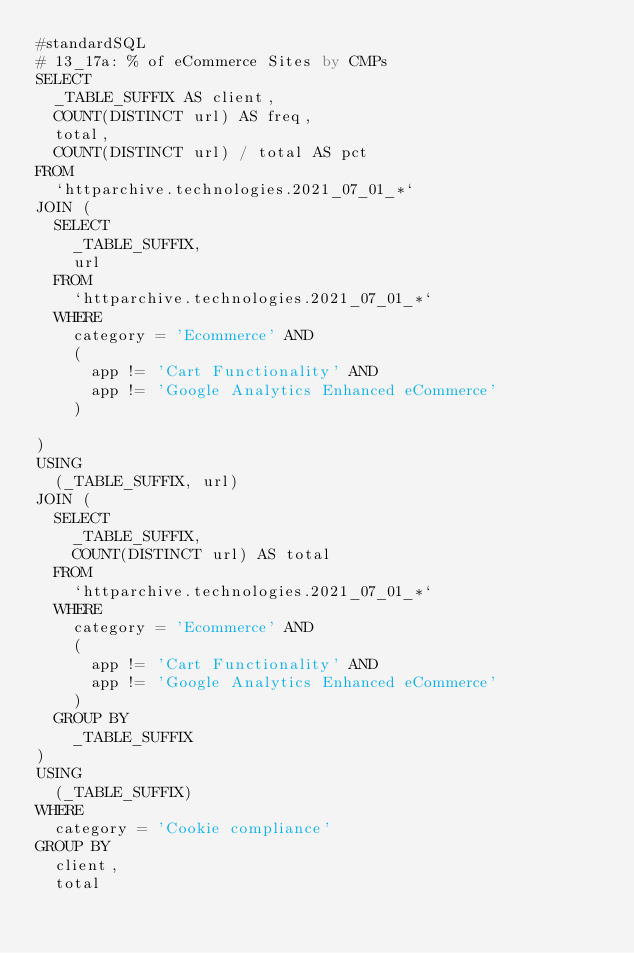Convert code to text. <code><loc_0><loc_0><loc_500><loc_500><_SQL_>#standardSQL
# 13_17a: % of eCommerce Sites by CMPs
SELECT
  _TABLE_SUFFIX AS client,
  COUNT(DISTINCT url) AS freq,
  total,
  COUNT(DISTINCT url) / total AS pct
FROM
  `httparchive.technologies.2021_07_01_*`
JOIN (
  SELECT
    _TABLE_SUFFIX,
    url
  FROM
    `httparchive.technologies.2021_07_01_*`
  WHERE
    category = 'Ecommerce' AND
    (
      app != 'Cart Functionality' AND
      app != 'Google Analytics Enhanced eCommerce'
    )

)
USING
  (_TABLE_SUFFIX, url)
JOIN (
  SELECT
    _TABLE_SUFFIX,
    COUNT(DISTINCT url) AS total
  FROM
    `httparchive.technologies.2021_07_01_*`
  WHERE
    category = 'Ecommerce' AND
    (
      app != 'Cart Functionality' AND
      app != 'Google Analytics Enhanced eCommerce'
    )
  GROUP BY
    _TABLE_SUFFIX
)
USING
  (_TABLE_SUFFIX)
WHERE
  category = 'Cookie compliance'
GROUP BY
  client,
  total
</code> 